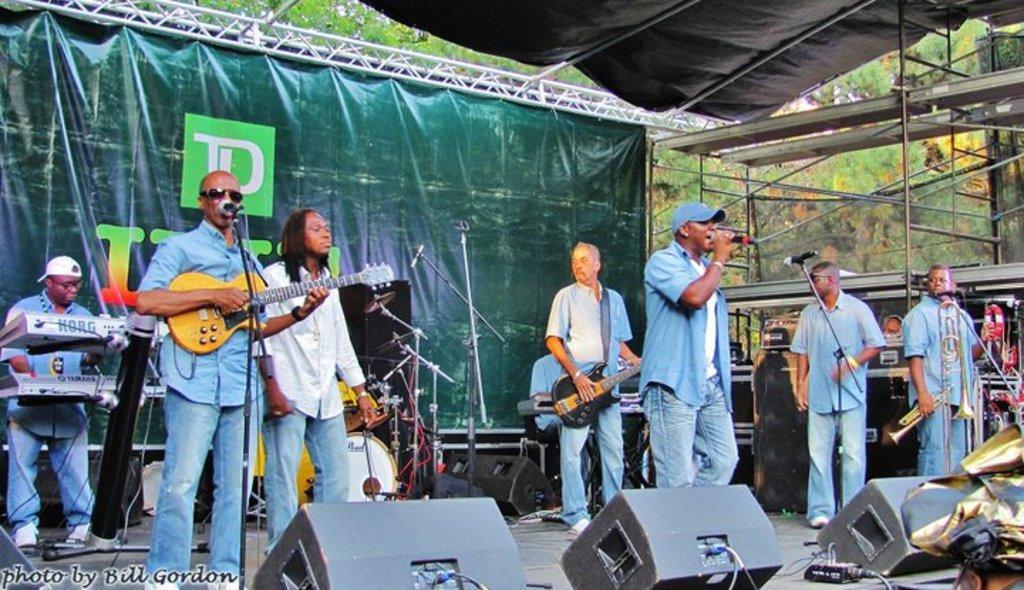How would you summarize this image in a sentence or two? Here we can see a band performing on stage, the person in the middle is singing a song with a microphone in his hand and rest others are playing musical instruments their respective musical instruments and there are lights and speakers present here and there and behind them we can see trees we can see plastic cover here and there 